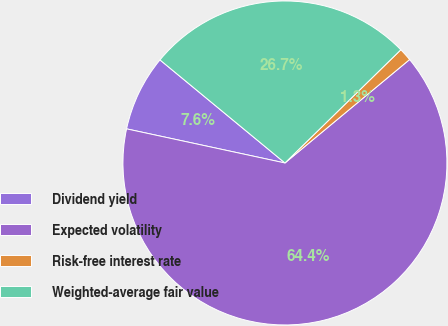Convert chart. <chart><loc_0><loc_0><loc_500><loc_500><pie_chart><fcel>Dividend yield<fcel>Expected volatility<fcel>Risk-free interest rate<fcel>Weighted-average fair value<nl><fcel>7.6%<fcel>64.4%<fcel>1.29%<fcel>26.71%<nl></chart> 